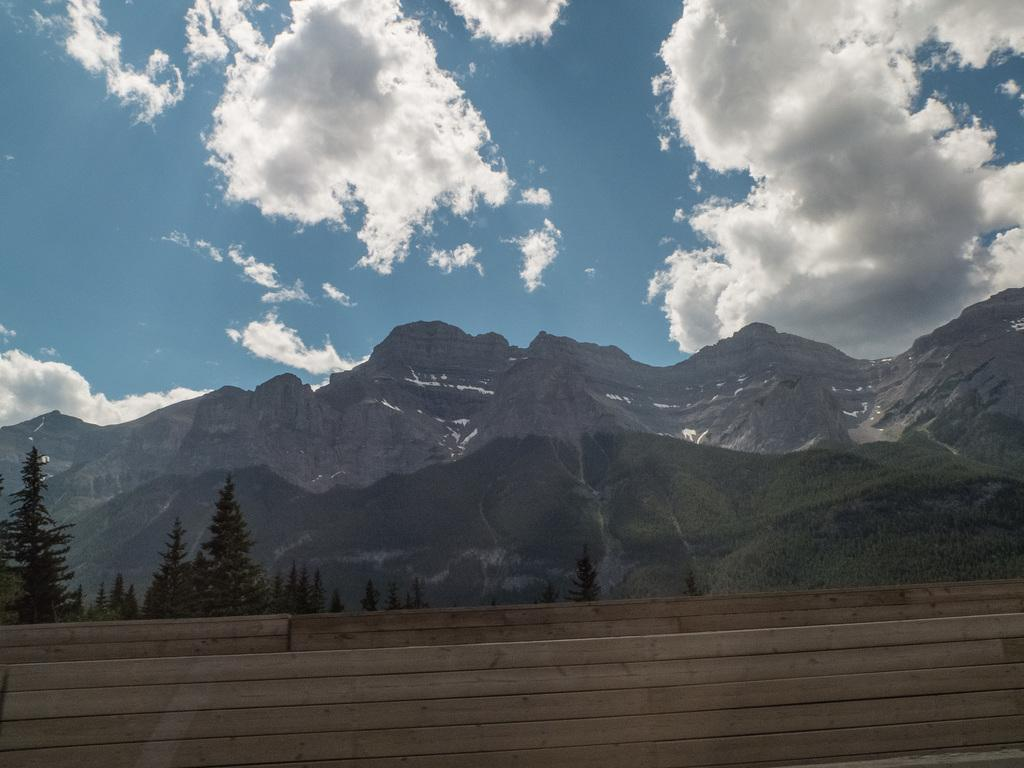Where was the image taken? The image was taken outside of the city. What type of structure can be seen in the image? There is a wood wall in the image. What type of natural elements are present in the image? There are trees, plants, and mountains in the image. What is visible in the sky in the image? The sky is visible in the image and is a bit cloudy. What arithmetic problem is being solved on the wood wall in the image? There is no arithmetic problem visible on the wood wall in the image. How comfortable is the seating arrangement in the image? The image does not show any seating arrangement, so it is not possible to determine the comfort level. 